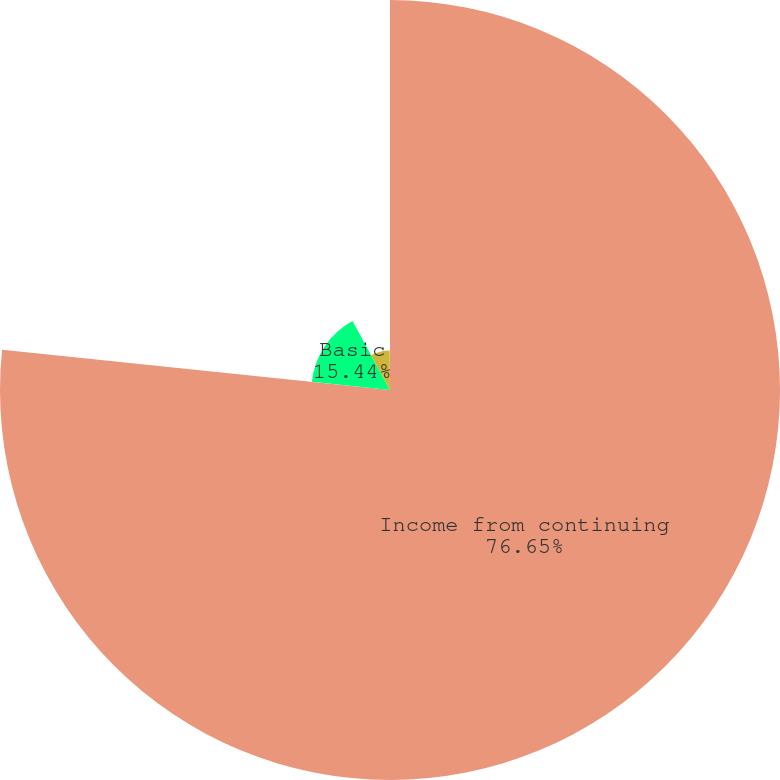Convert chart to OTSL. <chart><loc_0><loc_0><loc_500><loc_500><pie_chart><fcel>Income from continuing<fcel>Basic<fcel>Diluted<fcel>Dividends per share of common<nl><fcel>76.65%<fcel>15.44%<fcel>7.78%<fcel>0.13%<nl></chart> 